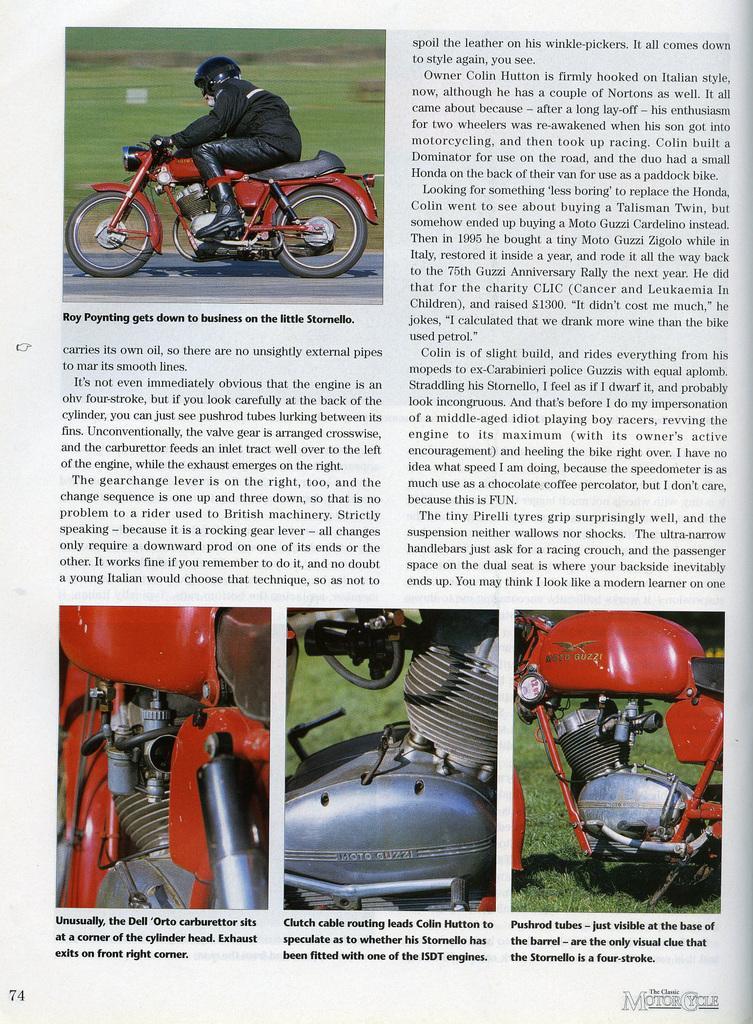Please provide a concise description of this image. In this picture we can see a paper and on this paper we can see a person wore a helmet and riding a motor bike on the road, grass, bike parts and some text. 